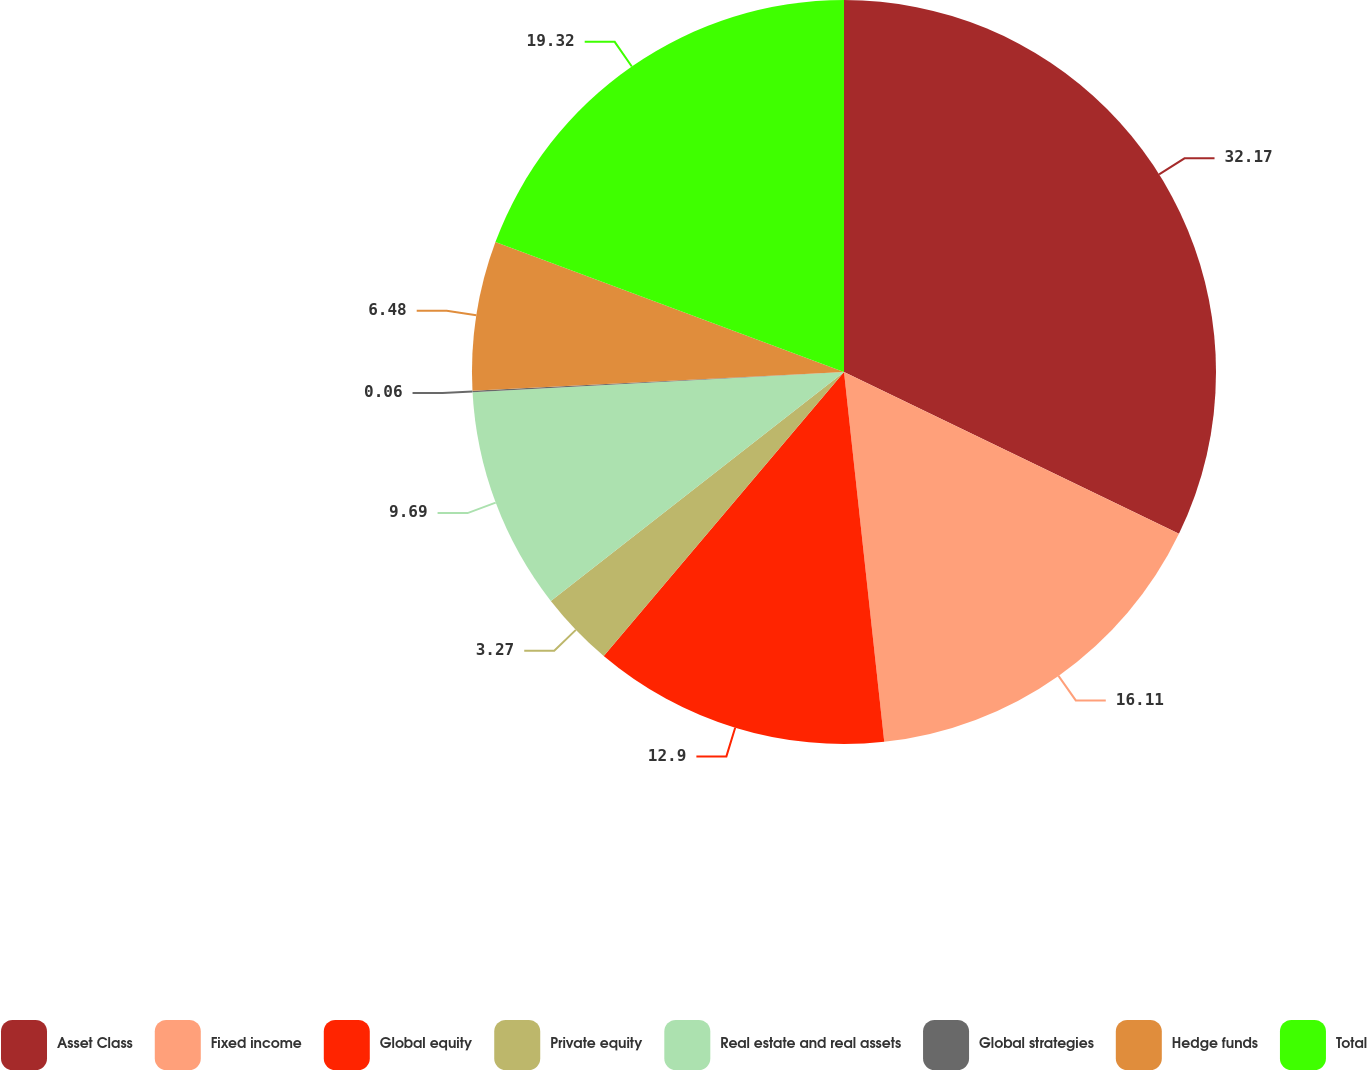<chart> <loc_0><loc_0><loc_500><loc_500><pie_chart><fcel>Asset Class<fcel>Fixed income<fcel>Global equity<fcel>Private equity<fcel>Real estate and real assets<fcel>Global strategies<fcel>Hedge funds<fcel>Total<nl><fcel>32.16%<fcel>16.11%<fcel>12.9%<fcel>3.27%<fcel>9.69%<fcel>0.06%<fcel>6.48%<fcel>19.32%<nl></chart> 